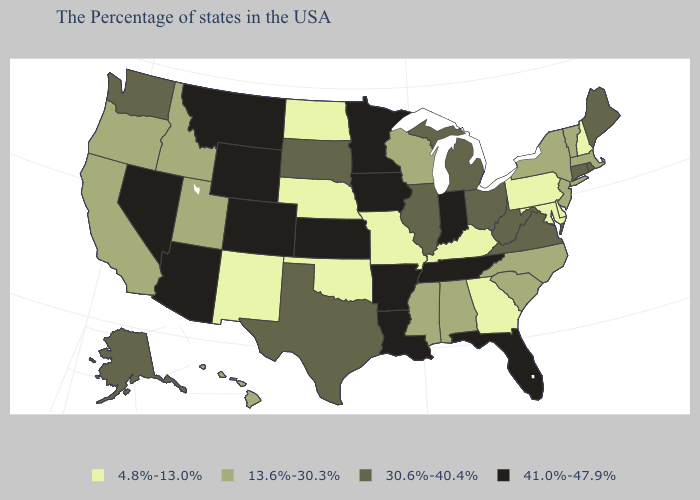Does the first symbol in the legend represent the smallest category?
Quick response, please. Yes. What is the value of Arkansas?
Keep it brief. 41.0%-47.9%. Among the states that border North Carolina , does Georgia have the lowest value?
Short answer required. Yes. How many symbols are there in the legend?
Write a very short answer. 4. What is the value of New Mexico?
Short answer required. 4.8%-13.0%. Which states have the highest value in the USA?
Keep it brief. Florida, Indiana, Tennessee, Louisiana, Arkansas, Minnesota, Iowa, Kansas, Wyoming, Colorado, Montana, Arizona, Nevada. Name the states that have a value in the range 4.8%-13.0%?
Write a very short answer. New Hampshire, Delaware, Maryland, Pennsylvania, Georgia, Kentucky, Missouri, Nebraska, Oklahoma, North Dakota, New Mexico. Name the states that have a value in the range 4.8%-13.0%?
Quick response, please. New Hampshire, Delaware, Maryland, Pennsylvania, Georgia, Kentucky, Missouri, Nebraska, Oklahoma, North Dakota, New Mexico. What is the value of Connecticut?
Short answer required. 30.6%-40.4%. Does Vermont have the highest value in the Northeast?
Quick response, please. No. Name the states that have a value in the range 41.0%-47.9%?
Concise answer only. Florida, Indiana, Tennessee, Louisiana, Arkansas, Minnesota, Iowa, Kansas, Wyoming, Colorado, Montana, Arizona, Nevada. What is the highest value in states that border New Mexico?
Keep it brief. 41.0%-47.9%. What is the value of Utah?
Give a very brief answer. 13.6%-30.3%. Does the map have missing data?
Be succinct. No. 